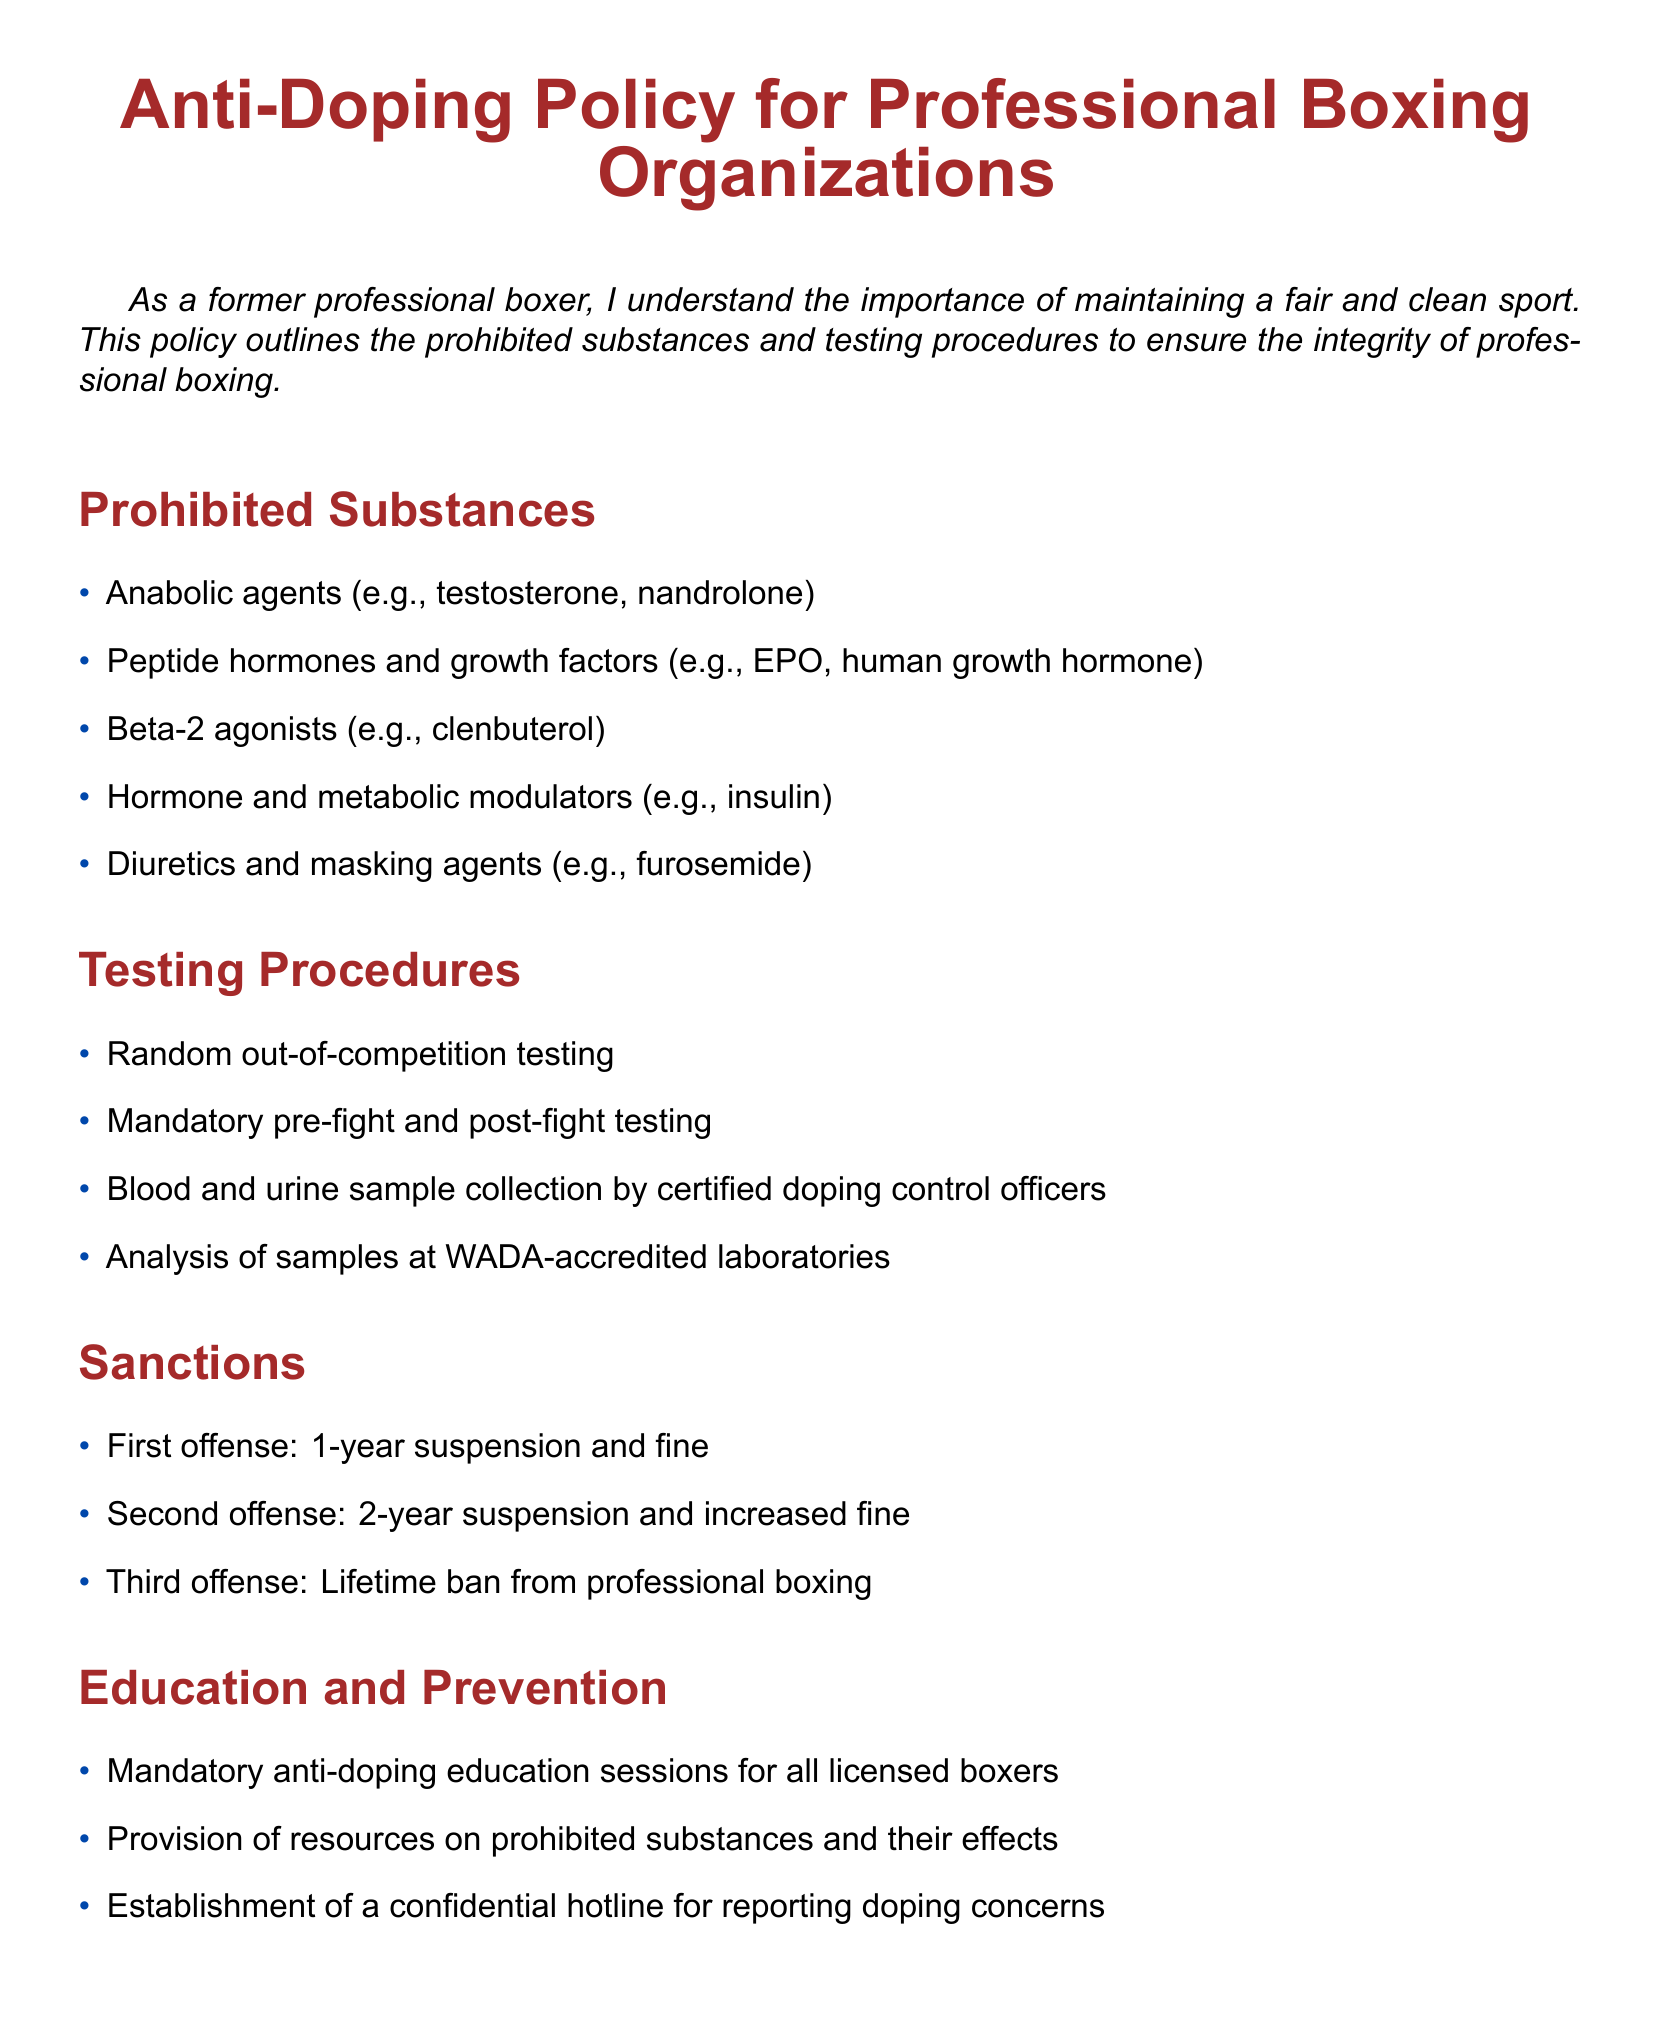What are anabolic agents? Anabolic agents are one category of prohibited substances listed in the document, and examples include testosterone and nandrolone.
Answer: testosterone, nandrolone How long is the first suspension? The document states a specific penalty for a first offense, which is a suspension period.
Answer: 1-year Which organization oversees this anti-doping policy? The document mentions multiple governing bodies related to this policy; therefore, identifying one of them would answer the question.
Answer: World Boxing Council (WBC) What type of samples are collected during testing? The document specifies the types of samples collected during testing procedures, which include both blood and urine.
Answer: blood and urine What happens after a third offense? The document outlines specific sanctions for multiple offenses, indicating what will occur after a third violation.
Answer: Lifetime ban from professional boxing What is the purpose of the education and prevention section? This section aims to provide resources and mandatory sessions to inform boxers about doping.
Answer: Mandatory anti-doping education sessions Which hormone is mentioned as a peptide hormone in the prohibited list? The document includes peptide hormones as a category of prohibited substances and provides a specific example.
Answer: EPO What is the consequence for a second offense? The document outlines penalties for doping violations, including a specific consequence for the second offense.
Answer: 2-year suspension and increased fine 